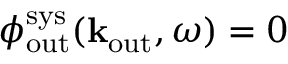<formula> <loc_0><loc_0><loc_500><loc_500>\phi _ { o u t } ^ { s y s } ( { k } _ { o u t } , \omega ) = 0</formula> 